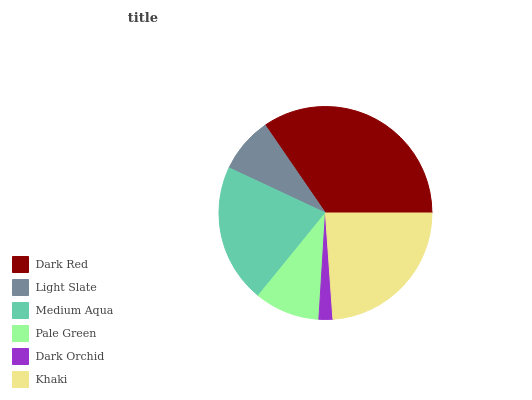Is Dark Orchid the minimum?
Answer yes or no. Yes. Is Dark Red the maximum?
Answer yes or no. Yes. Is Light Slate the minimum?
Answer yes or no. No. Is Light Slate the maximum?
Answer yes or no. No. Is Dark Red greater than Light Slate?
Answer yes or no. Yes. Is Light Slate less than Dark Red?
Answer yes or no. Yes. Is Light Slate greater than Dark Red?
Answer yes or no. No. Is Dark Red less than Light Slate?
Answer yes or no. No. Is Medium Aqua the high median?
Answer yes or no. Yes. Is Pale Green the low median?
Answer yes or no. Yes. Is Light Slate the high median?
Answer yes or no. No. Is Khaki the low median?
Answer yes or no. No. 